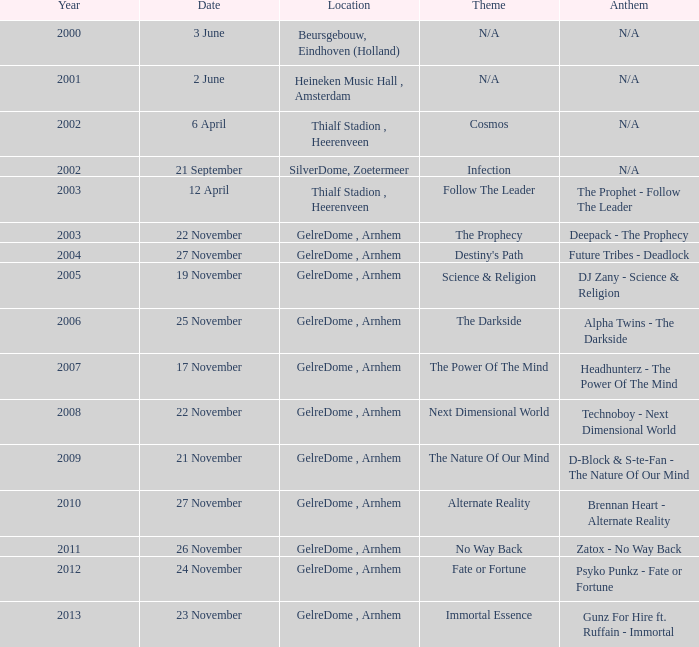In 2007, what was the location? GelreDome , Arnhem. 